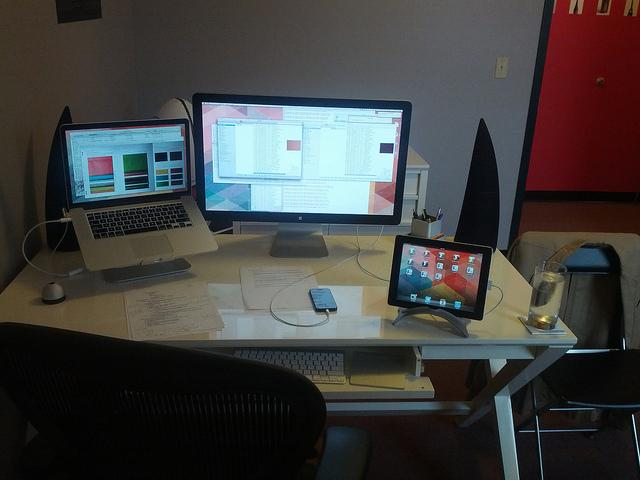What is on the table?

Choices:
A) plate
B) cat
C) laptop
D) fork laptop 